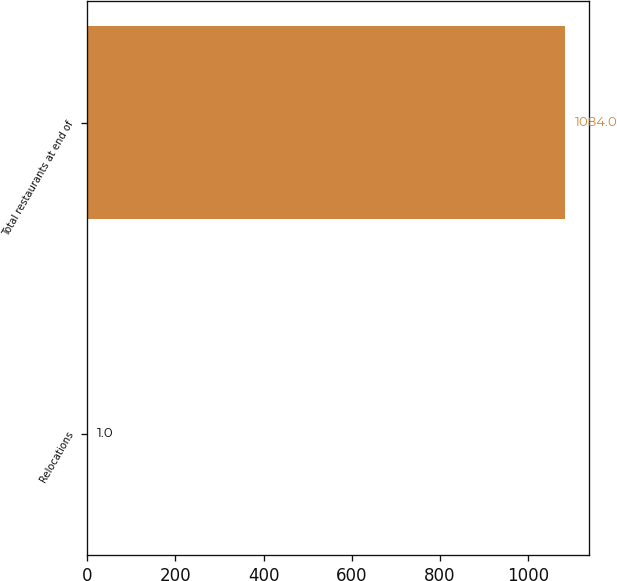Convert chart to OTSL. <chart><loc_0><loc_0><loc_500><loc_500><bar_chart><fcel>Relocations<fcel>Total restaurants at end of<nl><fcel>1<fcel>1084<nl></chart> 